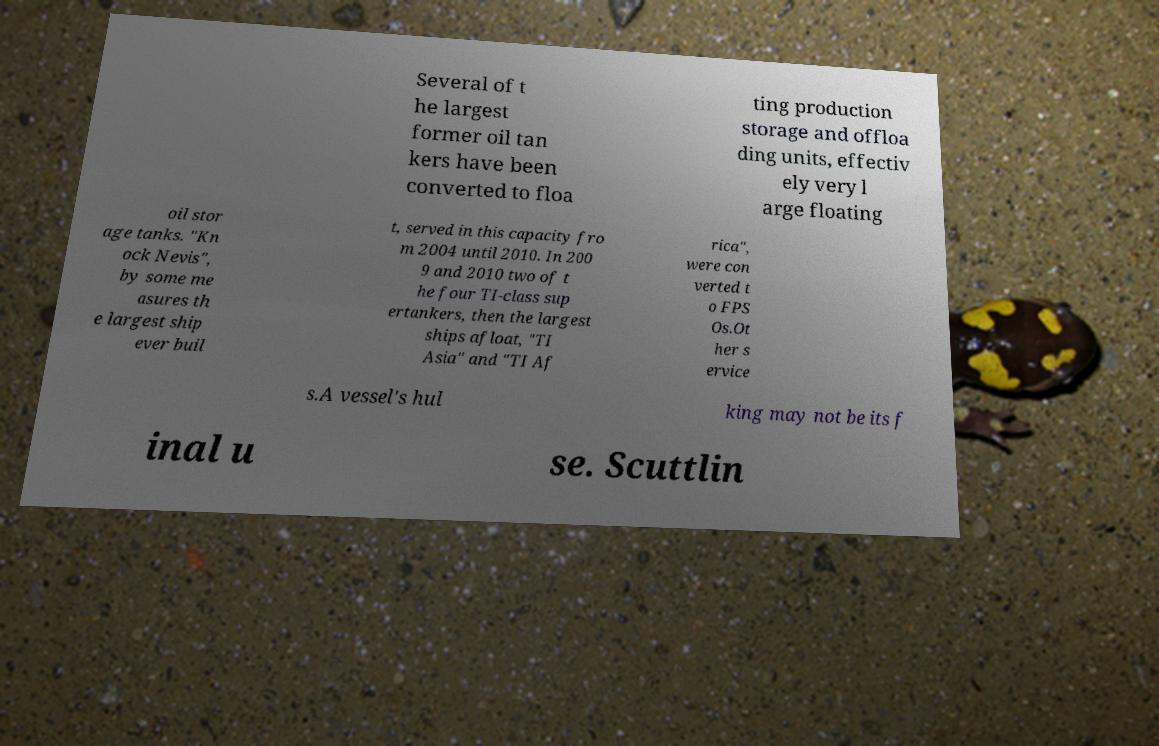I need the written content from this picture converted into text. Can you do that? Several of t he largest former oil tan kers have been converted to floa ting production storage and offloa ding units, effectiv ely very l arge floating oil stor age tanks. "Kn ock Nevis", by some me asures th e largest ship ever buil t, served in this capacity fro m 2004 until 2010. In 200 9 and 2010 two of t he four TI-class sup ertankers, then the largest ships afloat, "TI Asia" and "TI Af rica", were con verted t o FPS Os.Ot her s ervice s.A vessel's hul king may not be its f inal u se. Scuttlin 